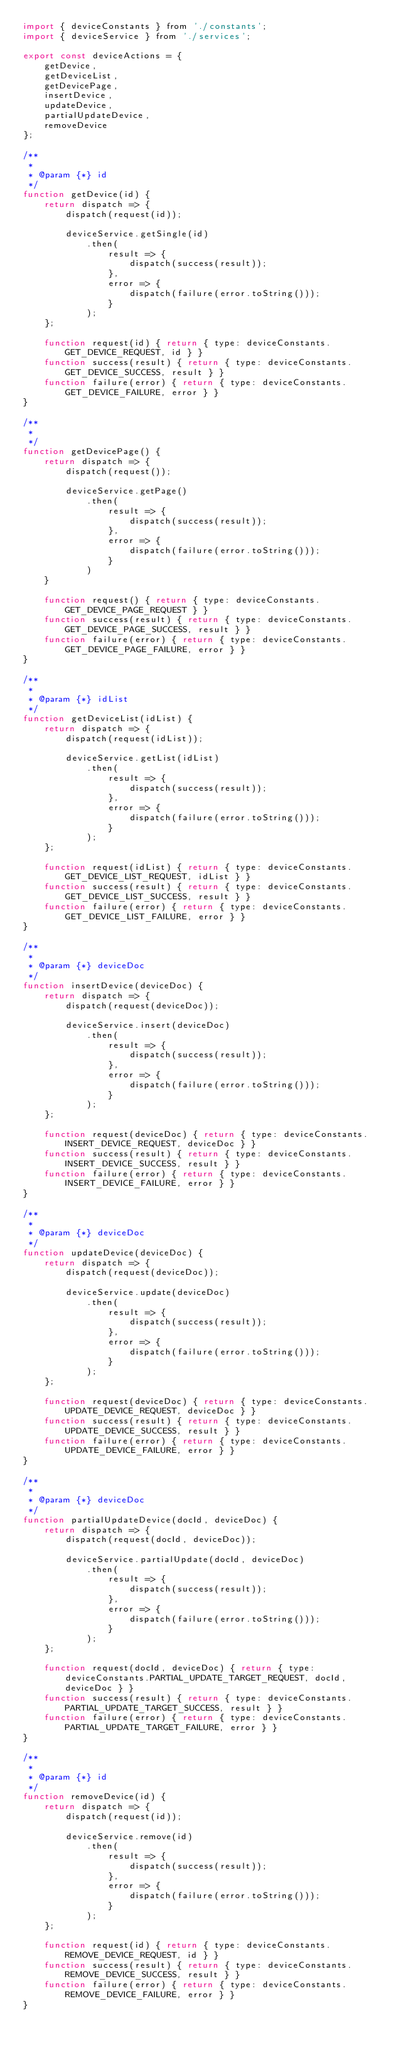Convert code to text. <code><loc_0><loc_0><loc_500><loc_500><_JavaScript_>import { deviceConstants } from './constants';
import { deviceService } from './services';

export const deviceActions = {
    getDevice,
    getDeviceList,
    getDevicePage,
    insertDevice,
    updateDevice,
    partialUpdateDevice,
    removeDevice
};

/**
 * 
 * @param {*} id 
 */
function getDevice(id) {
    return dispatch => {
        dispatch(request(id));

        deviceService.getSingle(id)
            .then(
                result => {
                    dispatch(success(result));
                },
                error => {
                    dispatch(failure(error.toString()));
                }
            );
    };

    function request(id) { return { type: deviceConstants.GET_DEVICE_REQUEST, id } }
    function success(result) { return { type: deviceConstants.GET_DEVICE_SUCCESS, result } }
    function failure(error) { return { type: deviceConstants.GET_DEVICE_FAILURE, error } }
}

/**
 * 
 */
function getDevicePage() {
    return dispatch => {
        dispatch(request());

        deviceService.getPage()
            .then(
                result => {
                    dispatch(success(result));
                },
                error => {
                    dispatch(failure(error.toString()));
                }
            )
    }

    function request() { return { type: deviceConstants.GET_DEVICE_PAGE_REQUEST } }
    function success(result) { return { type: deviceConstants.GET_DEVICE_PAGE_SUCCESS, result } }
    function failure(error) { return { type: deviceConstants.GET_DEVICE_PAGE_FAILURE, error } }
}

/**
 * 
 * @param {*} idList 
 */
function getDeviceList(idList) {
    return dispatch => {
        dispatch(request(idList));

        deviceService.getList(idList)
            .then(
                result => {
                    dispatch(success(result));
                },
                error => {
                    dispatch(failure(error.toString()));
                }
            );
    };

    function request(idList) { return { type: deviceConstants.GET_DEVICE_LIST_REQUEST, idList } }
    function success(result) { return { type: deviceConstants.GET_DEVICE_LIST_SUCCESS, result } }
    function failure(error) { return { type: deviceConstants.GET_DEVICE_LIST_FAILURE, error } }
}

/**
 * 
 * @param {*} deviceDoc 
 */
function insertDevice(deviceDoc) {
    return dispatch => {
        dispatch(request(deviceDoc));

        deviceService.insert(deviceDoc)
            .then(
                result => {
                    dispatch(success(result));
                },
                error => {
                    dispatch(failure(error.toString()));
                }
            );
    };

    function request(deviceDoc) { return { type: deviceConstants.INSERT_DEVICE_REQUEST, deviceDoc } }
    function success(result) { return { type: deviceConstants.INSERT_DEVICE_SUCCESS, result } }
    function failure(error) { return { type: deviceConstants.INSERT_DEVICE_FAILURE, error } }
}

/**
 * 
 * @param {*} deviceDoc 
 */
function updateDevice(deviceDoc) {
    return dispatch => {
        dispatch(request(deviceDoc));

        deviceService.update(deviceDoc)
            .then(
                result => {
                    dispatch(success(result));
                },
                error => {
                    dispatch(failure(error.toString()));
                }
            );
    };

    function request(deviceDoc) { return { type: deviceConstants.UPDATE_DEVICE_REQUEST, deviceDoc } }
    function success(result) { return { type: deviceConstants.UPDATE_DEVICE_SUCCESS, result } }
    function failure(error) { return { type: deviceConstants.UPDATE_DEVICE_FAILURE, error } }
}

/**
 * 
 * @param {*} deviceDoc 
 */
function partialUpdateDevice(docId, deviceDoc) {
    return dispatch => {
        dispatch(request(docId, deviceDoc));

        deviceService.partialUpdate(docId, deviceDoc)
            .then(
                result => {
                    dispatch(success(result));
                },
                error => {
                    dispatch(failure(error.toString()));
                }
            );
    };

    function request(docId, deviceDoc) { return { type: deviceConstants.PARTIAL_UPDATE_TARGET_REQUEST, docId, deviceDoc } }
    function success(result) { return { type: deviceConstants.PARTIAL_UPDATE_TARGET_SUCCESS, result } }
    function failure(error) { return { type: deviceConstants.PARTIAL_UPDATE_TARGET_FAILURE, error } }
}

/**
 * 
 * @param {*} id 
 */
function removeDevice(id) {
    return dispatch => {
        dispatch(request(id));

        deviceService.remove(id)
            .then(
                result => {
                    dispatch(success(result));
                },
                error => {
                    dispatch(failure(error.toString()));
                }
            );
    };

    function request(id) { return { type: deviceConstants.REMOVE_DEVICE_REQUEST, id } }
    function success(result) { return { type: deviceConstants.REMOVE_DEVICE_SUCCESS, result } }
    function failure(error) { return { type: deviceConstants.REMOVE_DEVICE_FAILURE, error } }
}</code> 